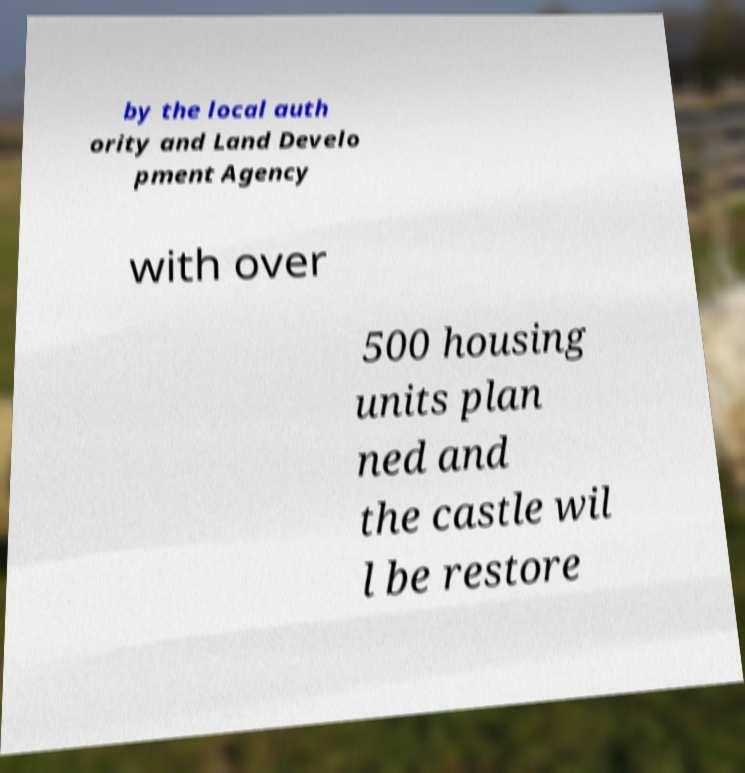Please identify and transcribe the text found in this image. by the local auth ority and Land Develo pment Agency with over 500 housing units plan ned and the castle wil l be restore 